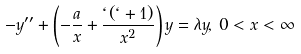<formula> <loc_0><loc_0><loc_500><loc_500>- y ^ { \prime \prime } + \left ( - \frac { a } { x } + \frac { \ell ( \ell + 1 ) } { x ^ { 2 } } \right ) y = \lambda y , \, 0 < x < \infty</formula> 